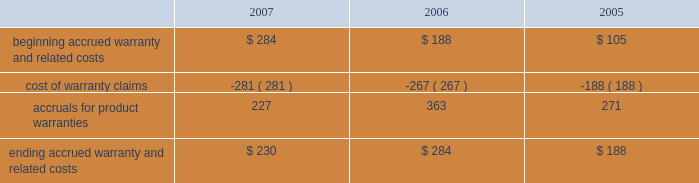Notes to consolidated financial statements ( continued ) note 8 2014commitments and contingencies ( continued ) the table reconciles changes in the company 2019s accrued warranties and related costs ( in millions ) : .
The company generally does not indemnify end-users of its operating system and application software against legal claims that the software infringes third-party intellectual property rights .
Other agreements entered into by the company sometimes include indemnification provisions under which the company could be subject to costs and/or damages in the event of an infringement claim against the company or an indemnified third-party .
However , the company has not been required to make any significant payments resulting from such an infringement claim asserted against itself or an indemnified third-party and , in the opinion of management , does not have a potential liability related to unresolved infringement claims subject to indemnification that would have a material adverse effect on its financial condition or operating results .
Therefore , the company did not record a liability for infringement costs as of either september 29 , 2007 or september 30 , 2006 .
Concentrations in the available sources of supply of materials and product certain key components including , but not limited to , microprocessors , enclosures , certain lcds , certain optical drives , and application-specific integrated circuits ( 2018 2018asics 2019 2019 ) are currently obtained by the company from single or limited sources which subjects the company to supply and pricing risks .
Many of these and other key components that are available from multiple sources including , but not limited to , nand flash memory , dram memory , and certain lcds , are at times subject to industry-wide shortages and significant commodity pricing fluctuations .
In addition , the company has entered into certain agreements for the supply of critical components at favorable pricing , and there is no guarantee that the company will be able to extend or renew these agreements when they expire .
Therefore , the company remains subject to significant risks of supply shortages and/or price increases that can adversely affect gross margins and operating margins .
In addition , the company uses some components that are not common to the rest of the global personal computer , consumer electronics and mobile communication industries , and new products introduced by the company often utilize custom components obtained from only one source until the company has evaluated whether there is a need for and subsequently qualifies additional suppliers .
If the supply of a key single-sourced component to the company were to be delayed or curtailed , or in the event a key manufacturing vendor delays shipments of completed products to the company , the company 2019s ability to ship related products in desired quantities and in a timely manner could be adversely affected .
The company 2019s business and financial performance could also be adversely affected depending on the time required to obtain sufficient quantities from the original source , or to identify and obtain sufficient quantities from an alternative source .
Continued availability of these components may be affected if producers were to decide to concentrate on the production of common components instead of components customized to meet the company 2019s requirements .
Finally , significant portions of the company 2019s cpus , ipods , iphones , logic boards , and other assembled products are now manufactured by outsourcing partners , primarily in various parts of asia .
A significant concentration of this outsourced manufacturing is currently performed by only a few of the company 2019s outsourcing partners , often in single locations .
Certain of these outsourcing partners are the sole-sourced supplier of components and manufacturing outsourcing for many of the company 2019s key products , including but not limited to , assembly .
What was the percentage change in accrued warranties and related costs from 2005 to 2006? 
Computations: ((284 - 188) / 188)
Answer: 0.51064. 